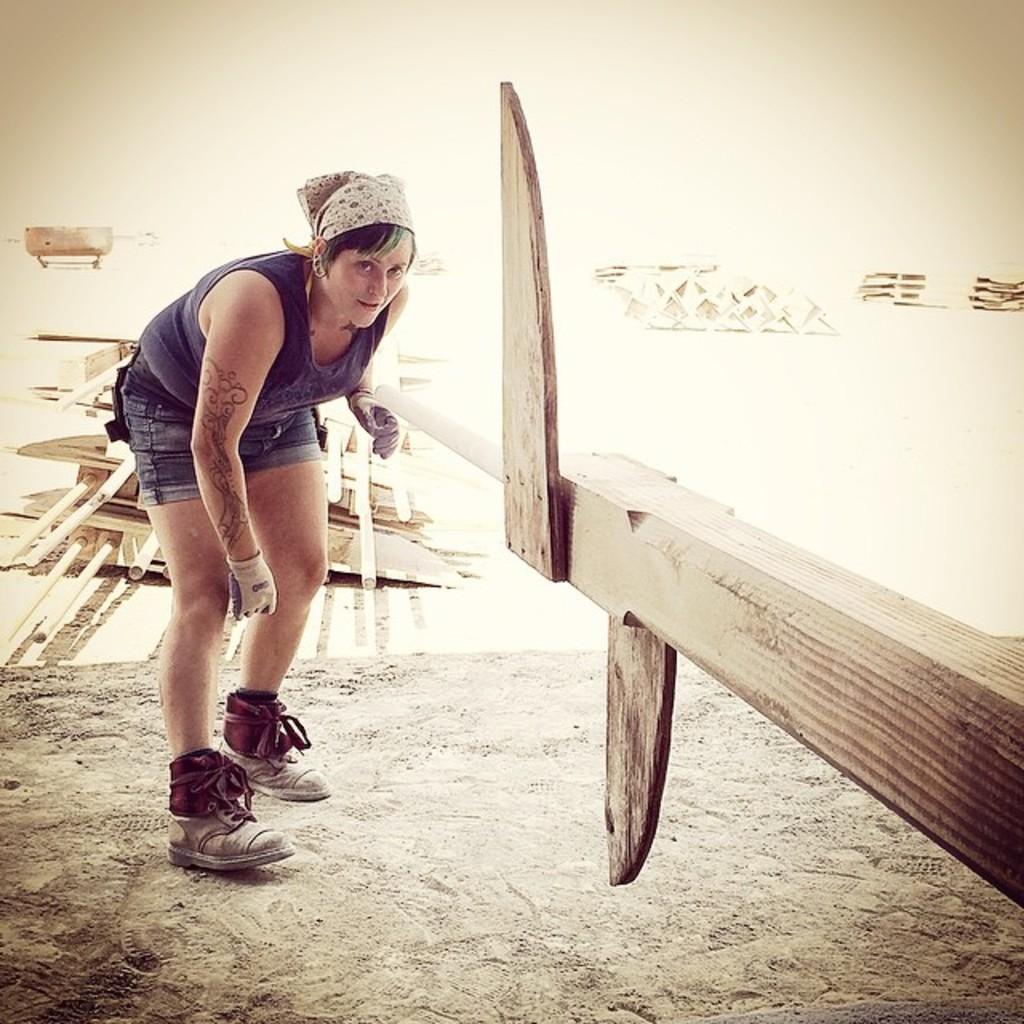Can you describe this image briefly? In this image there is a woman in the middle who is standing on the ground by holding the wooden stick which is in front of her. In the background there are poles on the ground. 